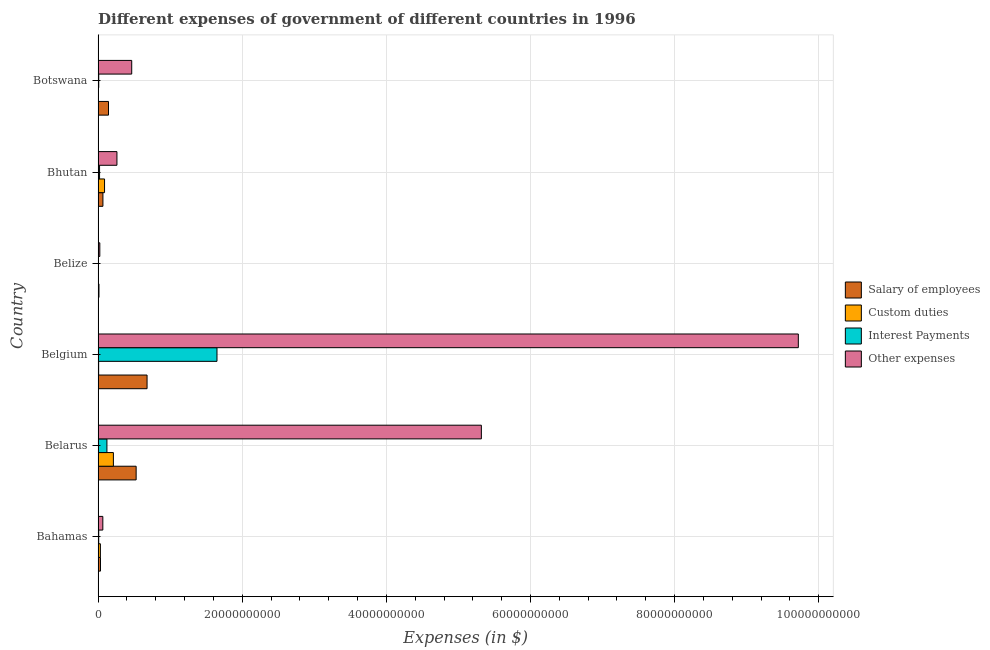How many different coloured bars are there?
Make the answer very short. 4. How many groups of bars are there?
Offer a very short reply. 6. Are the number of bars per tick equal to the number of legend labels?
Keep it short and to the point. Yes. How many bars are there on the 3rd tick from the top?
Offer a terse response. 4. How many bars are there on the 1st tick from the bottom?
Offer a very short reply. 4. What is the label of the 3rd group of bars from the top?
Your answer should be compact. Belize. What is the amount spent on interest payments in Belize?
Ensure brevity in your answer.  2.83e+07. Across all countries, what is the maximum amount spent on custom duties?
Provide a short and direct response. 2.12e+09. Across all countries, what is the minimum amount spent on interest payments?
Your answer should be very brief. 2.83e+07. In which country was the amount spent on custom duties maximum?
Provide a short and direct response. Belarus. In which country was the amount spent on interest payments minimum?
Make the answer very short. Belize. What is the total amount spent on interest payments in the graph?
Your answer should be compact. 1.81e+1. What is the difference between the amount spent on interest payments in Belarus and that in Bhutan?
Offer a terse response. 1.02e+09. What is the difference between the amount spent on interest payments in Botswana and the amount spent on salary of employees in Belarus?
Ensure brevity in your answer.  -5.19e+09. What is the average amount spent on salary of employees per country?
Your answer should be compact. 2.44e+09. What is the difference between the amount spent on interest payments and amount spent on custom duties in Botswana?
Your response must be concise. 6.23e+07. In how many countries, is the amount spent on custom duties greater than 56000000000 $?
Provide a short and direct response. 0. What is the ratio of the amount spent on salary of employees in Belarus to that in Botswana?
Ensure brevity in your answer.  3.66. What is the difference between the highest and the second highest amount spent on other expenses?
Your answer should be compact. 4.40e+1. What is the difference between the highest and the lowest amount spent on custom duties?
Your response must be concise. 2.11e+09. Is it the case that in every country, the sum of the amount spent on salary of employees and amount spent on other expenses is greater than the sum of amount spent on custom duties and amount spent on interest payments?
Provide a short and direct response. No. What does the 1st bar from the top in Belize represents?
Ensure brevity in your answer.  Other expenses. What does the 1st bar from the bottom in Botswana represents?
Provide a succinct answer. Salary of employees. Are all the bars in the graph horizontal?
Your answer should be very brief. Yes. How many countries are there in the graph?
Your answer should be very brief. 6. Are the values on the major ticks of X-axis written in scientific E-notation?
Keep it short and to the point. No. Does the graph contain any zero values?
Provide a short and direct response. No. Does the graph contain grids?
Give a very brief answer. Yes. Where does the legend appear in the graph?
Ensure brevity in your answer.  Center right. How many legend labels are there?
Ensure brevity in your answer.  4. How are the legend labels stacked?
Ensure brevity in your answer.  Vertical. What is the title of the graph?
Offer a terse response. Different expenses of government of different countries in 1996. What is the label or title of the X-axis?
Offer a terse response. Expenses (in $). What is the Expenses (in $) in Salary of employees in Bahamas?
Keep it short and to the point. 3.34e+08. What is the Expenses (in $) of Custom duties in Bahamas?
Make the answer very short. 3.20e+08. What is the Expenses (in $) of Interest Payments in Bahamas?
Your response must be concise. 8.74e+07. What is the Expenses (in $) in Other expenses in Bahamas?
Provide a succinct answer. 6.59e+08. What is the Expenses (in $) of Salary of employees in Belarus?
Provide a short and direct response. 5.28e+09. What is the Expenses (in $) of Custom duties in Belarus?
Give a very brief answer. 2.12e+09. What is the Expenses (in $) of Interest Payments in Belarus?
Give a very brief answer. 1.23e+09. What is the Expenses (in $) of Other expenses in Belarus?
Offer a terse response. 5.32e+1. What is the Expenses (in $) in Salary of employees in Belgium?
Your answer should be very brief. 6.80e+09. What is the Expenses (in $) in Custom duties in Belgium?
Make the answer very short. 7.93e+07. What is the Expenses (in $) of Interest Payments in Belgium?
Make the answer very short. 1.65e+1. What is the Expenses (in $) in Other expenses in Belgium?
Offer a very short reply. 9.72e+1. What is the Expenses (in $) of Salary of employees in Belize?
Your answer should be compact. 1.23e+08. What is the Expenses (in $) in Custom duties in Belize?
Make the answer very short. 1.91e+07. What is the Expenses (in $) in Interest Payments in Belize?
Make the answer very short. 2.83e+07. What is the Expenses (in $) of Other expenses in Belize?
Your answer should be compact. 2.40e+08. What is the Expenses (in $) of Salary of employees in Bhutan?
Your answer should be very brief. 6.72e+08. What is the Expenses (in $) of Custom duties in Bhutan?
Make the answer very short. 8.96e+08. What is the Expenses (in $) in Interest Payments in Bhutan?
Your answer should be very brief. 2.06e+08. What is the Expenses (in $) of Other expenses in Bhutan?
Offer a terse response. 2.62e+09. What is the Expenses (in $) of Salary of employees in Botswana?
Offer a very short reply. 1.44e+09. What is the Expenses (in $) of Custom duties in Botswana?
Provide a succinct answer. 2.91e+07. What is the Expenses (in $) in Interest Payments in Botswana?
Make the answer very short. 9.14e+07. What is the Expenses (in $) in Other expenses in Botswana?
Make the answer very short. 4.67e+09. Across all countries, what is the maximum Expenses (in $) of Salary of employees?
Provide a succinct answer. 6.80e+09. Across all countries, what is the maximum Expenses (in $) of Custom duties?
Give a very brief answer. 2.12e+09. Across all countries, what is the maximum Expenses (in $) of Interest Payments?
Offer a very short reply. 1.65e+1. Across all countries, what is the maximum Expenses (in $) of Other expenses?
Your answer should be compact. 9.72e+1. Across all countries, what is the minimum Expenses (in $) in Salary of employees?
Ensure brevity in your answer.  1.23e+08. Across all countries, what is the minimum Expenses (in $) of Custom duties?
Offer a terse response. 1.91e+07. Across all countries, what is the minimum Expenses (in $) in Interest Payments?
Provide a short and direct response. 2.83e+07. Across all countries, what is the minimum Expenses (in $) in Other expenses?
Ensure brevity in your answer.  2.40e+08. What is the total Expenses (in $) in Salary of employees in the graph?
Your response must be concise. 1.47e+1. What is the total Expenses (in $) of Custom duties in the graph?
Keep it short and to the point. 3.47e+09. What is the total Expenses (in $) in Interest Payments in the graph?
Ensure brevity in your answer.  1.81e+1. What is the total Expenses (in $) of Other expenses in the graph?
Your answer should be compact. 1.59e+11. What is the difference between the Expenses (in $) of Salary of employees in Bahamas and that in Belarus?
Keep it short and to the point. -4.95e+09. What is the difference between the Expenses (in $) in Custom duties in Bahamas and that in Belarus?
Your response must be concise. -1.80e+09. What is the difference between the Expenses (in $) of Interest Payments in Bahamas and that in Belarus?
Your answer should be compact. -1.14e+09. What is the difference between the Expenses (in $) in Other expenses in Bahamas and that in Belarus?
Ensure brevity in your answer.  -5.25e+1. What is the difference between the Expenses (in $) of Salary of employees in Bahamas and that in Belgium?
Offer a very short reply. -6.46e+09. What is the difference between the Expenses (in $) in Custom duties in Bahamas and that in Belgium?
Your answer should be very brief. 2.40e+08. What is the difference between the Expenses (in $) in Interest Payments in Bahamas and that in Belgium?
Your answer should be very brief. -1.64e+1. What is the difference between the Expenses (in $) of Other expenses in Bahamas and that in Belgium?
Make the answer very short. -9.65e+1. What is the difference between the Expenses (in $) in Salary of employees in Bahamas and that in Belize?
Your response must be concise. 2.11e+08. What is the difference between the Expenses (in $) of Custom duties in Bahamas and that in Belize?
Provide a succinct answer. 3.01e+08. What is the difference between the Expenses (in $) of Interest Payments in Bahamas and that in Belize?
Your response must be concise. 5.91e+07. What is the difference between the Expenses (in $) of Other expenses in Bahamas and that in Belize?
Provide a short and direct response. 4.19e+08. What is the difference between the Expenses (in $) of Salary of employees in Bahamas and that in Bhutan?
Provide a succinct answer. -3.39e+08. What is the difference between the Expenses (in $) in Custom duties in Bahamas and that in Bhutan?
Keep it short and to the point. -5.76e+08. What is the difference between the Expenses (in $) in Interest Payments in Bahamas and that in Bhutan?
Offer a terse response. -1.18e+08. What is the difference between the Expenses (in $) in Other expenses in Bahamas and that in Bhutan?
Provide a succinct answer. -1.96e+09. What is the difference between the Expenses (in $) of Salary of employees in Bahamas and that in Botswana?
Your answer should be compact. -1.11e+09. What is the difference between the Expenses (in $) of Custom duties in Bahamas and that in Botswana?
Offer a terse response. 2.91e+08. What is the difference between the Expenses (in $) of Interest Payments in Bahamas and that in Botswana?
Your answer should be compact. -4.00e+06. What is the difference between the Expenses (in $) of Other expenses in Bahamas and that in Botswana?
Give a very brief answer. -4.01e+09. What is the difference between the Expenses (in $) of Salary of employees in Belarus and that in Belgium?
Provide a short and direct response. -1.51e+09. What is the difference between the Expenses (in $) of Custom duties in Belarus and that in Belgium?
Offer a terse response. 2.04e+09. What is the difference between the Expenses (in $) of Interest Payments in Belarus and that in Belgium?
Give a very brief answer. -1.53e+1. What is the difference between the Expenses (in $) in Other expenses in Belarus and that in Belgium?
Keep it short and to the point. -4.40e+1. What is the difference between the Expenses (in $) in Salary of employees in Belarus and that in Belize?
Provide a short and direct response. 5.16e+09. What is the difference between the Expenses (in $) in Custom duties in Belarus and that in Belize?
Your answer should be very brief. 2.11e+09. What is the difference between the Expenses (in $) of Interest Payments in Belarus and that in Belize?
Your answer should be very brief. 1.20e+09. What is the difference between the Expenses (in $) in Other expenses in Belarus and that in Belize?
Your answer should be very brief. 5.29e+1. What is the difference between the Expenses (in $) of Salary of employees in Belarus and that in Bhutan?
Provide a short and direct response. 4.61e+09. What is the difference between the Expenses (in $) in Custom duties in Belarus and that in Bhutan?
Provide a succinct answer. 1.23e+09. What is the difference between the Expenses (in $) of Interest Payments in Belarus and that in Bhutan?
Your answer should be compact. 1.02e+09. What is the difference between the Expenses (in $) in Other expenses in Belarus and that in Bhutan?
Offer a terse response. 5.06e+1. What is the difference between the Expenses (in $) in Salary of employees in Belarus and that in Botswana?
Offer a very short reply. 3.84e+09. What is the difference between the Expenses (in $) in Custom duties in Belarus and that in Botswana?
Your answer should be compact. 2.10e+09. What is the difference between the Expenses (in $) in Interest Payments in Belarus and that in Botswana?
Offer a terse response. 1.14e+09. What is the difference between the Expenses (in $) in Other expenses in Belarus and that in Botswana?
Your response must be concise. 4.85e+1. What is the difference between the Expenses (in $) of Salary of employees in Belgium and that in Belize?
Provide a short and direct response. 6.67e+09. What is the difference between the Expenses (in $) of Custom duties in Belgium and that in Belize?
Make the answer very short. 6.02e+07. What is the difference between the Expenses (in $) in Interest Payments in Belgium and that in Belize?
Provide a succinct answer. 1.65e+1. What is the difference between the Expenses (in $) of Other expenses in Belgium and that in Belize?
Ensure brevity in your answer.  9.69e+1. What is the difference between the Expenses (in $) of Salary of employees in Belgium and that in Bhutan?
Provide a short and direct response. 6.12e+09. What is the difference between the Expenses (in $) of Custom duties in Belgium and that in Bhutan?
Make the answer very short. -8.17e+08. What is the difference between the Expenses (in $) in Interest Payments in Belgium and that in Bhutan?
Provide a short and direct response. 1.63e+1. What is the difference between the Expenses (in $) of Other expenses in Belgium and that in Bhutan?
Make the answer very short. 9.46e+1. What is the difference between the Expenses (in $) of Salary of employees in Belgium and that in Botswana?
Keep it short and to the point. 5.35e+09. What is the difference between the Expenses (in $) in Custom duties in Belgium and that in Botswana?
Give a very brief answer. 5.02e+07. What is the difference between the Expenses (in $) of Interest Payments in Belgium and that in Botswana?
Your response must be concise. 1.64e+1. What is the difference between the Expenses (in $) of Other expenses in Belgium and that in Botswana?
Your response must be concise. 9.25e+1. What is the difference between the Expenses (in $) of Salary of employees in Belize and that in Bhutan?
Offer a very short reply. -5.49e+08. What is the difference between the Expenses (in $) in Custom duties in Belize and that in Bhutan?
Your answer should be compact. -8.77e+08. What is the difference between the Expenses (in $) in Interest Payments in Belize and that in Bhutan?
Offer a terse response. -1.77e+08. What is the difference between the Expenses (in $) of Other expenses in Belize and that in Bhutan?
Ensure brevity in your answer.  -2.38e+09. What is the difference between the Expenses (in $) of Salary of employees in Belize and that in Botswana?
Make the answer very short. -1.32e+09. What is the difference between the Expenses (in $) in Custom duties in Belize and that in Botswana?
Provide a short and direct response. -1.00e+07. What is the difference between the Expenses (in $) in Interest Payments in Belize and that in Botswana?
Your response must be concise. -6.31e+07. What is the difference between the Expenses (in $) of Other expenses in Belize and that in Botswana?
Provide a short and direct response. -4.43e+09. What is the difference between the Expenses (in $) in Salary of employees in Bhutan and that in Botswana?
Provide a succinct answer. -7.72e+08. What is the difference between the Expenses (in $) of Custom duties in Bhutan and that in Botswana?
Provide a succinct answer. 8.67e+08. What is the difference between the Expenses (in $) in Interest Payments in Bhutan and that in Botswana?
Your response must be concise. 1.14e+08. What is the difference between the Expenses (in $) in Other expenses in Bhutan and that in Botswana?
Offer a terse response. -2.05e+09. What is the difference between the Expenses (in $) of Salary of employees in Bahamas and the Expenses (in $) of Custom duties in Belarus?
Make the answer very short. -1.79e+09. What is the difference between the Expenses (in $) in Salary of employees in Bahamas and the Expenses (in $) in Interest Payments in Belarus?
Your answer should be compact. -8.93e+08. What is the difference between the Expenses (in $) of Salary of employees in Bahamas and the Expenses (in $) of Other expenses in Belarus?
Keep it short and to the point. -5.29e+1. What is the difference between the Expenses (in $) in Custom duties in Bahamas and the Expenses (in $) in Interest Payments in Belarus?
Provide a succinct answer. -9.07e+08. What is the difference between the Expenses (in $) of Custom duties in Bahamas and the Expenses (in $) of Other expenses in Belarus?
Give a very brief answer. -5.29e+1. What is the difference between the Expenses (in $) of Interest Payments in Bahamas and the Expenses (in $) of Other expenses in Belarus?
Your response must be concise. -5.31e+1. What is the difference between the Expenses (in $) in Salary of employees in Bahamas and the Expenses (in $) in Custom duties in Belgium?
Give a very brief answer. 2.54e+08. What is the difference between the Expenses (in $) of Salary of employees in Bahamas and the Expenses (in $) of Interest Payments in Belgium?
Make the answer very short. -1.62e+1. What is the difference between the Expenses (in $) in Salary of employees in Bahamas and the Expenses (in $) in Other expenses in Belgium?
Ensure brevity in your answer.  -9.68e+1. What is the difference between the Expenses (in $) in Custom duties in Bahamas and the Expenses (in $) in Interest Payments in Belgium?
Provide a succinct answer. -1.62e+1. What is the difference between the Expenses (in $) in Custom duties in Bahamas and the Expenses (in $) in Other expenses in Belgium?
Offer a very short reply. -9.68e+1. What is the difference between the Expenses (in $) in Interest Payments in Bahamas and the Expenses (in $) in Other expenses in Belgium?
Offer a very short reply. -9.71e+1. What is the difference between the Expenses (in $) of Salary of employees in Bahamas and the Expenses (in $) of Custom duties in Belize?
Make the answer very short. 3.15e+08. What is the difference between the Expenses (in $) in Salary of employees in Bahamas and the Expenses (in $) in Interest Payments in Belize?
Your response must be concise. 3.05e+08. What is the difference between the Expenses (in $) in Salary of employees in Bahamas and the Expenses (in $) in Other expenses in Belize?
Your answer should be very brief. 9.38e+07. What is the difference between the Expenses (in $) of Custom duties in Bahamas and the Expenses (in $) of Interest Payments in Belize?
Your response must be concise. 2.91e+08. What is the difference between the Expenses (in $) in Custom duties in Bahamas and the Expenses (in $) in Other expenses in Belize?
Offer a very short reply. 7.98e+07. What is the difference between the Expenses (in $) in Interest Payments in Bahamas and the Expenses (in $) in Other expenses in Belize?
Ensure brevity in your answer.  -1.53e+08. What is the difference between the Expenses (in $) of Salary of employees in Bahamas and the Expenses (in $) of Custom duties in Bhutan?
Keep it short and to the point. -5.62e+08. What is the difference between the Expenses (in $) in Salary of employees in Bahamas and the Expenses (in $) in Interest Payments in Bhutan?
Provide a short and direct response. 1.28e+08. What is the difference between the Expenses (in $) of Salary of employees in Bahamas and the Expenses (in $) of Other expenses in Bhutan?
Provide a short and direct response. -2.28e+09. What is the difference between the Expenses (in $) of Custom duties in Bahamas and the Expenses (in $) of Interest Payments in Bhutan?
Ensure brevity in your answer.  1.14e+08. What is the difference between the Expenses (in $) of Custom duties in Bahamas and the Expenses (in $) of Other expenses in Bhutan?
Keep it short and to the point. -2.30e+09. What is the difference between the Expenses (in $) of Interest Payments in Bahamas and the Expenses (in $) of Other expenses in Bhutan?
Ensure brevity in your answer.  -2.53e+09. What is the difference between the Expenses (in $) of Salary of employees in Bahamas and the Expenses (in $) of Custom duties in Botswana?
Offer a terse response. 3.05e+08. What is the difference between the Expenses (in $) in Salary of employees in Bahamas and the Expenses (in $) in Interest Payments in Botswana?
Ensure brevity in your answer.  2.42e+08. What is the difference between the Expenses (in $) in Salary of employees in Bahamas and the Expenses (in $) in Other expenses in Botswana?
Offer a very short reply. -4.33e+09. What is the difference between the Expenses (in $) of Custom duties in Bahamas and the Expenses (in $) of Interest Payments in Botswana?
Offer a terse response. 2.28e+08. What is the difference between the Expenses (in $) in Custom duties in Bahamas and the Expenses (in $) in Other expenses in Botswana?
Your response must be concise. -4.35e+09. What is the difference between the Expenses (in $) of Interest Payments in Bahamas and the Expenses (in $) of Other expenses in Botswana?
Give a very brief answer. -4.58e+09. What is the difference between the Expenses (in $) in Salary of employees in Belarus and the Expenses (in $) in Custom duties in Belgium?
Your response must be concise. 5.20e+09. What is the difference between the Expenses (in $) in Salary of employees in Belarus and the Expenses (in $) in Interest Payments in Belgium?
Give a very brief answer. -1.12e+1. What is the difference between the Expenses (in $) of Salary of employees in Belarus and the Expenses (in $) of Other expenses in Belgium?
Your response must be concise. -9.19e+1. What is the difference between the Expenses (in $) in Custom duties in Belarus and the Expenses (in $) in Interest Payments in Belgium?
Your response must be concise. -1.44e+1. What is the difference between the Expenses (in $) in Custom duties in Belarus and the Expenses (in $) in Other expenses in Belgium?
Your answer should be very brief. -9.50e+1. What is the difference between the Expenses (in $) in Interest Payments in Belarus and the Expenses (in $) in Other expenses in Belgium?
Give a very brief answer. -9.59e+1. What is the difference between the Expenses (in $) of Salary of employees in Belarus and the Expenses (in $) of Custom duties in Belize?
Your answer should be very brief. 5.26e+09. What is the difference between the Expenses (in $) of Salary of employees in Belarus and the Expenses (in $) of Interest Payments in Belize?
Ensure brevity in your answer.  5.25e+09. What is the difference between the Expenses (in $) of Salary of employees in Belarus and the Expenses (in $) of Other expenses in Belize?
Your answer should be compact. 5.04e+09. What is the difference between the Expenses (in $) of Custom duties in Belarus and the Expenses (in $) of Interest Payments in Belize?
Make the answer very short. 2.10e+09. What is the difference between the Expenses (in $) of Custom duties in Belarus and the Expenses (in $) of Other expenses in Belize?
Your answer should be compact. 1.88e+09. What is the difference between the Expenses (in $) of Interest Payments in Belarus and the Expenses (in $) of Other expenses in Belize?
Provide a succinct answer. 9.87e+08. What is the difference between the Expenses (in $) of Salary of employees in Belarus and the Expenses (in $) of Custom duties in Bhutan?
Give a very brief answer. 4.39e+09. What is the difference between the Expenses (in $) in Salary of employees in Belarus and the Expenses (in $) in Interest Payments in Bhutan?
Give a very brief answer. 5.08e+09. What is the difference between the Expenses (in $) in Salary of employees in Belarus and the Expenses (in $) in Other expenses in Bhutan?
Your response must be concise. 2.67e+09. What is the difference between the Expenses (in $) in Custom duties in Belarus and the Expenses (in $) in Interest Payments in Bhutan?
Give a very brief answer. 1.92e+09. What is the difference between the Expenses (in $) of Custom duties in Belarus and the Expenses (in $) of Other expenses in Bhutan?
Keep it short and to the point. -4.92e+08. What is the difference between the Expenses (in $) of Interest Payments in Belarus and the Expenses (in $) of Other expenses in Bhutan?
Your answer should be very brief. -1.39e+09. What is the difference between the Expenses (in $) in Salary of employees in Belarus and the Expenses (in $) in Custom duties in Botswana?
Your answer should be very brief. 5.25e+09. What is the difference between the Expenses (in $) in Salary of employees in Belarus and the Expenses (in $) in Interest Payments in Botswana?
Give a very brief answer. 5.19e+09. What is the difference between the Expenses (in $) of Salary of employees in Belarus and the Expenses (in $) of Other expenses in Botswana?
Provide a short and direct response. 6.14e+08. What is the difference between the Expenses (in $) in Custom duties in Belarus and the Expenses (in $) in Interest Payments in Botswana?
Your response must be concise. 2.03e+09. What is the difference between the Expenses (in $) of Custom duties in Belarus and the Expenses (in $) of Other expenses in Botswana?
Your answer should be compact. -2.54e+09. What is the difference between the Expenses (in $) in Interest Payments in Belarus and the Expenses (in $) in Other expenses in Botswana?
Your answer should be very brief. -3.44e+09. What is the difference between the Expenses (in $) in Salary of employees in Belgium and the Expenses (in $) in Custom duties in Belize?
Provide a short and direct response. 6.78e+09. What is the difference between the Expenses (in $) of Salary of employees in Belgium and the Expenses (in $) of Interest Payments in Belize?
Your answer should be very brief. 6.77e+09. What is the difference between the Expenses (in $) of Salary of employees in Belgium and the Expenses (in $) of Other expenses in Belize?
Make the answer very short. 6.56e+09. What is the difference between the Expenses (in $) of Custom duties in Belgium and the Expenses (in $) of Interest Payments in Belize?
Your answer should be compact. 5.10e+07. What is the difference between the Expenses (in $) in Custom duties in Belgium and the Expenses (in $) in Other expenses in Belize?
Your answer should be very brief. -1.61e+08. What is the difference between the Expenses (in $) in Interest Payments in Belgium and the Expenses (in $) in Other expenses in Belize?
Your response must be concise. 1.63e+1. What is the difference between the Expenses (in $) of Salary of employees in Belgium and the Expenses (in $) of Custom duties in Bhutan?
Provide a short and direct response. 5.90e+09. What is the difference between the Expenses (in $) in Salary of employees in Belgium and the Expenses (in $) in Interest Payments in Bhutan?
Provide a short and direct response. 6.59e+09. What is the difference between the Expenses (in $) of Salary of employees in Belgium and the Expenses (in $) of Other expenses in Bhutan?
Give a very brief answer. 4.18e+09. What is the difference between the Expenses (in $) of Custom duties in Belgium and the Expenses (in $) of Interest Payments in Bhutan?
Your answer should be compact. -1.26e+08. What is the difference between the Expenses (in $) in Custom duties in Belgium and the Expenses (in $) in Other expenses in Bhutan?
Make the answer very short. -2.54e+09. What is the difference between the Expenses (in $) in Interest Payments in Belgium and the Expenses (in $) in Other expenses in Bhutan?
Your answer should be compact. 1.39e+1. What is the difference between the Expenses (in $) of Salary of employees in Belgium and the Expenses (in $) of Custom duties in Botswana?
Offer a terse response. 6.77e+09. What is the difference between the Expenses (in $) in Salary of employees in Belgium and the Expenses (in $) in Interest Payments in Botswana?
Give a very brief answer. 6.70e+09. What is the difference between the Expenses (in $) of Salary of employees in Belgium and the Expenses (in $) of Other expenses in Botswana?
Your response must be concise. 2.13e+09. What is the difference between the Expenses (in $) in Custom duties in Belgium and the Expenses (in $) in Interest Payments in Botswana?
Ensure brevity in your answer.  -1.21e+07. What is the difference between the Expenses (in $) in Custom duties in Belgium and the Expenses (in $) in Other expenses in Botswana?
Ensure brevity in your answer.  -4.59e+09. What is the difference between the Expenses (in $) in Interest Payments in Belgium and the Expenses (in $) in Other expenses in Botswana?
Your answer should be compact. 1.18e+1. What is the difference between the Expenses (in $) of Salary of employees in Belize and the Expenses (in $) of Custom duties in Bhutan?
Provide a short and direct response. -7.73e+08. What is the difference between the Expenses (in $) in Salary of employees in Belize and the Expenses (in $) in Interest Payments in Bhutan?
Your answer should be very brief. -8.24e+07. What is the difference between the Expenses (in $) of Salary of employees in Belize and the Expenses (in $) of Other expenses in Bhutan?
Make the answer very short. -2.49e+09. What is the difference between the Expenses (in $) in Custom duties in Belize and the Expenses (in $) in Interest Payments in Bhutan?
Keep it short and to the point. -1.86e+08. What is the difference between the Expenses (in $) in Custom duties in Belize and the Expenses (in $) in Other expenses in Bhutan?
Your answer should be compact. -2.60e+09. What is the difference between the Expenses (in $) of Interest Payments in Belize and the Expenses (in $) of Other expenses in Bhutan?
Provide a succinct answer. -2.59e+09. What is the difference between the Expenses (in $) in Salary of employees in Belize and the Expenses (in $) in Custom duties in Botswana?
Offer a terse response. 9.40e+07. What is the difference between the Expenses (in $) in Salary of employees in Belize and the Expenses (in $) in Interest Payments in Botswana?
Offer a terse response. 3.17e+07. What is the difference between the Expenses (in $) of Salary of employees in Belize and the Expenses (in $) of Other expenses in Botswana?
Provide a short and direct response. -4.54e+09. What is the difference between the Expenses (in $) in Custom duties in Belize and the Expenses (in $) in Interest Payments in Botswana?
Ensure brevity in your answer.  -7.23e+07. What is the difference between the Expenses (in $) of Custom duties in Belize and the Expenses (in $) of Other expenses in Botswana?
Your response must be concise. -4.65e+09. What is the difference between the Expenses (in $) in Interest Payments in Belize and the Expenses (in $) in Other expenses in Botswana?
Your answer should be compact. -4.64e+09. What is the difference between the Expenses (in $) in Salary of employees in Bhutan and the Expenses (in $) in Custom duties in Botswana?
Your response must be concise. 6.43e+08. What is the difference between the Expenses (in $) in Salary of employees in Bhutan and the Expenses (in $) in Interest Payments in Botswana?
Your answer should be very brief. 5.81e+08. What is the difference between the Expenses (in $) of Salary of employees in Bhutan and the Expenses (in $) of Other expenses in Botswana?
Your response must be concise. -3.99e+09. What is the difference between the Expenses (in $) of Custom duties in Bhutan and the Expenses (in $) of Interest Payments in Botswana?
Offer a very short reply. 8.05e+08. What is the difference between the Expenses (in $) of Custom duties in Bhutan and the Expenses (in $) of Other expenses in Botswana?
Your answer should be compact. -3.77e+09. What is the difference between the Expenses (in $) of Interest Payments in Bhutan and the Expenses (in $) of Other expenses in Botswana?
Provide a short and direct response. -4.46e+09. What is the average Expenses (in $) in Salary of employees per country?
Your answer should be compact. 2.44e+09. What is the average Expenses (in $) in Custom duties per country?
Offer a terse response. 5.78e+08. What is the average Expenses (in $) in Interest Payments per country?
Ensure brevity in your answer.  3.02e+09. What is the average Expenses (in $) of Other expenses per country?
Your answer should be very brief. 2.64e+1. What is the difference between the Expenses (in $) of Salary of employees and Expenses (in $) of Custom duties in Bahamas?
Make the answer very short. 1.40e+07. What is the difference between the Expenses (in $) in Salary of employees and Expenses (in $) in Interest Payments in Bahamas?
Keep it short and to the point. 2.46e+08. What is the difference between the Expenses (in $) in Salary of employees and Expenses (in $) in Other expenses in Bahamas?
Ensure brevity in your answer.  -3.25e+08. What is the difference between the Expenses (in $) of Custom duties and Expenses (in $) of Interest Payments in Bahamas?
Offer a very short reply. 2.32e+08. What is the difference between the Expenses (in $) in Custom duties and Expenses (in $) in Other expenses in Bahamas?
Provide a succinct answer. -3.39e+08. What is the difference between the Expenses (in $) in Interest Payments and Expenses (in $) in Other expenses in Bahamas?
Offer a terse response. -5.72e+08. What is the difference between the Expenses (in $) in Salary of employees and Expenses (in $) in Custom duties in Belarus?
Your response must be concise. 3.16e+09. What is the difference between the Expenses (in $) in Salary of employees and Expenses (in $) in Interest Payments in Belarus?
Ensure brevity in your answer.  4.06e+09. What is the difference between the Expenses (in $) of Salary of employees and Expenses (in $) of Other expenses in Belarus?
Offer a terse response. -4.79e+1. What is the difference between the Expenses (in $) in Custom duties and Expenses (in $) in Interest Payments in Belarus?
Make the answer very short. 8.98e+08. What is the difference between the Expenses (in $) in Custom duties and Expenses (in $) in Other expenses in Belarus?
Offer a very short reply. -5.11e+1. What is the difference between the Expenses (in $) of Interest Payments and Expenses (in $) of Other expenses in Belarus?
Provide a succinct answer. -5.20e+1. What is the difference between the Expenses (in $) of Salary of employees and Expenses (in $) of Custom duties in Belgium?
Offer a very short reply. 6.72e+09. What is the difference between the Expenses (in $) in Salary of employees and Expenses (in $) in Interest Payments in Belgium?
Your answer should be very brief. -9.70e+09. What is the difference between the Expenses (in $) in Salary of employees and Expenses (in $) in Other expenses in Belgium?
Offer a terse response. -9.04e+1. What is the difference between the Expenses (in $) in Custom duties and Expenses (in $) in Interest Payments in Belgium?
Make the answer very short. -1.64e+1. What is the difference between the Expenses (in $) of Custom duties and Expenses (in $) of Other expenses in Belgium?
Keep it short and to the point. -9.71e+1. What is the difference between the Expenses (in $) of Interest Payments and Expenses (in $) of Other expenses in Belgium?
Make the answer very short. -8.07e+1. What is the difference between the Expenses (in $) of Salary of employees and Expenses (in $) of Custom duties in Belize?
Your response must be concise. 1.04e+08. What is the difference between the Expenses (in $) of Salary of employees and Expenses (in $) of Interest Payments in Belize?
Ensure brevity in your answer.  9.48e+07. What is the difference between the Expenses (in $) of Salary of employees and Expenses (in $) of Other expenses in Belize?
Make the answer very short. -1.17e+08. What is the difference between the Expenses (in $) in Custom duties and Expenses (in $) in Interest Payments in Belize?
Your response must be concise. -9.22e+06. What is the difference between the Expenses (in $) in Custom duties and Expenses (in $) in Other expenses in Belize?
Ensure brevity in your answer.  -2.21e+08. What is the difference between the Expenses (in $) in Interest Payments and Expenses (in $) in Other expenses in Belize?
Make the answer very short. -2.12e+08. What is the difference between the Expenses (in $) of Salary of employees and Expenses (in $) of Custom duties in Bhutan?
Ensure brevity in your answer.  -2.24e+08. What is the difference between the Expenses (in $) in Salary of employees and Expenses (in $) in Interest Payments in Bhutan?
Your answer should be compact. 4.67e+08. What is the difference between the Expenses (in $) in Salary of employees and Expenses (in $) in Other expenses in Bhutan?
Provide a succinct answer. -1.94e+09. What is the difference between the Expenses (in $) of Custom duties and Expenses (in $) of Interest Payments in Bhutan?
Provide a short and direct response. 6.91e+08. What is the difference between the Expenses (in $) in Custom duties and Expenses (in $) in Other expenses in Bhutan?
Your answer should be compact. -1.72e+09. What is the difference between the Expenses (in $) of Interest Payments and Expenses (in $) of Other expenses in Bhutan?
Provide a succinct answer. -2.41e+09. What is the difference between the Expenses (in $) of Salary of employees and Expenses (in $) of Custom duties in Botswana?
Offer a terse response. 1.42e+09. What is the difference between the Expenses (in $) in Salary of employees and Expenses (in $) in Interest Payments in Botswana?
Keep it short and to the point. 1.35e+09. What is the difference between the Expenses (in $) in Salary of employees and Expenses (in $) in Other expenses in Botswana?
Provide a succinct answer. -3.22e+09. What is the difference between the Expenses (in $) of Custom duties and Expenses (in $) of Interest Payments in Botswana?
Offer a terse response. -6.23e+07. What is the difference between the Expenses (in $) of Custom duties and Expenses (in $) of Other expenses in Botswana?
Your answer should be compact. -4.64e+09. What is the difference between the Expenses (in $) of Interest Payments and Expenses (in $) of Other expenses in Botswana?
Make the answer very short. -4.58e+09. What is the ratio of the Expenses (in $) of Salary of employees in Bahamas to that in Belarus?
Make the answer very short. 0.06. What is the ratio of the Expenses (in $) of Custom duties in Bahamas to that in Belarus?
Keep it short and to the point. 0.15. What is the ratio of the Expenses (in $) of Interest Payments in Bahamas to that in Belarus?
Your answer should be very brief. 0.07. What is the ratio of the Expenses (in $) in Other expenses in Bahamas to that in Belarus?
Your answer should be compact. 0.01. What is the ratio of the Expenses (in $) in Salary of employees in Bahamas to that in Belgium?
Your answer should be compact. 0.05. What is the ratio of the Expenses (in $) in Custom duties in Bahamas to that in Belgium?
Ensure brevity in your answer.  4.03. What is the ratio of the Expenses (in $) in Interest Payments in Bahamas to that in Belgium?
Make the answer very short. 0.01. What is the ratio of the Expenses (in $) in Other expenses in Bahamas to that in Belgium?
Offer a terse response. 0.01. What is the ratio of the Expenses (in $) of Salary of employees in Bahamas to that in Belize?
Provide a short and direct response. 2.71. What is the ratio of the Expenses (in $) in Custom duties in Bahamas to that in Belize?
Offer a terse response. 16.74. What is the ratio of the Expenses (in $) in Interest Payments in Bahamas to that in Belize?
Your response must be concise. 3.09. What is the ratio of the Expenses (in $) in Other expenses in Bahamas to that in Belize?
Keep it short and to the point. 2.75. What is the ratio of the Expenses (in $) of Salary of employees in Bahamas to that in Bhutan?
Provide a short and direct response. 0.5. What is the ratio of the Expenses (in $) of Custom duties in Bahamas to that in Bhutan?
Ensure brevity in your answer.  0.36. What is the ratio of the Expenses (in $) in Interest Payments in Bahamas to that in Bhutan?
Your answer should be very brief. 0.43. What is the ratio of the Expenses (in $) in Other expenses in Bahamas to that in Bhutan?
Keep it short and to the point. 0.25. What is the ratio of the Expenses (in $) of Salary of employees in Bahamas to that in Botswana?
Make the answer very short. 0.23. What is the ratio of the Expenses (in $) in Custom duties in Bahamas to that in Botswana?
Make the answer very short. 10.99. What is the ratio of the Expenses (in $) in Interest Payments in Bahamas to that in Botswana?
Offer a very short reply. 0.96. What is the ratio of the Expenses (in $) in Other expenses in Bahamas to that in Botswana?
Your response must be concise. 0.14. What is the ratio of the Expenses (in $) of Salary of employees in Belarus to that in Belgium?
Give a very brief answer. 0.78. What is the ratio of the Expenses (in $) of Custom duties in Belarus to that in Belgium?
Provide a short and direct response. 26.79. What is the ratio of the Expenses (in $) of Interest Payments in Belarus to that in Belgium?
Your response must be concise. 0.07. What is the ratio of the Expenses (in $) of Other expenses in Belarus to that in Belgium?
Your answer should be very brief. 0.55. What is the ratio of the Expenses (in $) of Salary of employees in Belarus to that in Belize?
Your response must be concise. 42.9. What is the ratio of the Expenses (in $) of Custom duties in Belarus to that in Belize?
Give a very brief answer. 111.22. What is the ratio of the Expenses (in $) in Interest Payments in Belarus to that in Belize?
Give a very brief answer. 43.32. What is the ratio of the Expenses (in $) in Other expenses in Belarus to that in Belize?
Keep it short and to the point. 221.67. What is the ratio of the Expenses (in $) of Salary of employees in Belarus to that in Bhutan?
Provide a succinct answer. 7.86. What is the ratio of the Expenses (in $) of Custom duties in Belarus to that in Bhutan?
Offer a very short reply. 2.37. What is the ratio of the Expenses (in $) of Interest Payments in Belarus to that in Bhutan?
Offer a very short reply. 5.97. What is the ratio of the Expenses (in $) in Other expenses in Belarus to that in Bhutan?
Ensure brevity in your answer.  20.33. What is the ratio of the Expenses (in $) in Salary of employees in Belarus to that in Botswana?
Keep it short and to the point. 3.66. What is the ratio of the Expenses (in $) of Interest Payments in Belarus to that in Botswana?
Provide a succinct answer. 13.42. What is the ratio of the Expenses (in $) of Other expenses in Belarus to that in Botswana?
Ensure brevity in your answer.  11.4. What is the ratio of the Expenses (in $) in Salary of employees in Belgium to that in Belize?
Provide a short and direct response. 55.2. What is the ratio of the Expenses (in $) of Custom duties in Belgium to that in Belize?
Give a very brief answer. 4.15. What is the ratio of the Expenses (in $) in Interest Payments in Belgium to that in Belize?
Offer a terse response. 582.55. What is the ratio of the Expenses (in $) in Other expenses in Belgium to that in Belize?
Keep it short and to the point. 404.99. What is the ratio of the Expenses (in $) in Salary of employees in Belgium to that in Bhutan?
Your response must be concise. 10.11. What is the ratio of the Expenses (in $) of Custom duties in Belgium to that in Bhutan?
Your answer should be compact. 0.09. What is the ratio of the Expenses (in $) of Interest Payments in Belgium to that in Bhutan?
Your response must be concise. 80.29. What is the ratio of the Expenses (in $) of Other expenses in Belgium to that in Bhutan?
Your answer should be compact. 37.14. What is the ratio of the Expenses (in $) in Salary of employees in Belgium to that in Botswana?
Provide a succinct answer. 4.7. What is the ratio of the Expenses (in $) of Custom duties in Belgium to that in Botswana?
Ensure brevity in your answer.  2.73. What is the ratio of the Expenses (in $) of Interest Payments in Belgium to that in Botswana?
Offer a terse response. 180.52. What is the ratio of the Expenses (in $) in Other expenses in Belgium to that in Botswana?
Give a very brief answer. 20.82. What is the ratio of the Expenses (in $) of Salary of employees in Belize to that in Bhutan?
Your response must be concise. 0.18. What is the ratio of the Expenses (in $) in Custom duties in Belize to that in Bhutan?
Keep it short and to the point. 0.02. What is the ratio of the Expenses (in $) in Interest Payments in Belize to that in Bhutan?
Ensure brevity in your answer.  0.14. What is the ratio of the Expenses (in $) in Other expenses in Belize to that in Bhutan?
Provide a short and direct response. 0.09. What is the ratio of the Expenses (in $) of Salary of employees in Belize to that in Botswana?
Provide a short and direct response. 0.09. What is the ratio of the Expenses (in $) of Custom duties in Belize to that in Botswana?
Your answer should be compact. 0.66. What is the ratio of the Expenses (in $) of Interest Payments in Belize to that in Botswana?
Give a very brief answer. 0.31. What is the ratio of the Expenses (in $) of Other expenses in Belize to that in Botswana?
Make the answer very short. 0.05. What is the ratio of the Expenses (in $) in Salary of employees in Bhutan to that in Botswana?
Make the answer very short. 0.47. What is the ratio of the Expenses (in $) in Custom duties in Bhutan to that in Botswana?
Provide a short and direct response. 30.8. What is the ratio of the Expenses (in $) of Interest Payments in Bhutan to that in Botswana?
Provide a succinct answer. 2.25. What is the ratio of the Expenses (in $) in Other expenses in Bhutan to that in Botswana?
Your response must be concise. 0.56. What is the difference between the highest and the second highest Expenses (in $) of Salary of employees?
Make the answer very short. 1.51e+09. What is the difference between the highest and the second highest Expenses (in $) in Custom duties?
Provide a short and direct response. 1.23e+09. What is the difference between the highest and the second highest Expenses (in $) of Interest Payments?
Your answer should be very brief. 1.53e+1. What is the difference between the highest and the second highest Expenses (in $) of Other expenses?
Your response must be concise. 4.40e+1. What is the difference between the highest and the lowest Expenses (in $) of Salary of employees?
Ensure brevity in your answer.  6.67e+09. What is the difference between the highest and the lowest Expenses (in $) in Custom duties?
Provide a short and direct response. 2.11e+09. What is the difference between the highest and the lowest Expenses (in $) of Interest Payments?
Make the answer very short. 1.65e+1. What is the difference between the highest and the lowest Expenses (in $) of Other expenses?
Your response must be concise. 9.69e+1. 